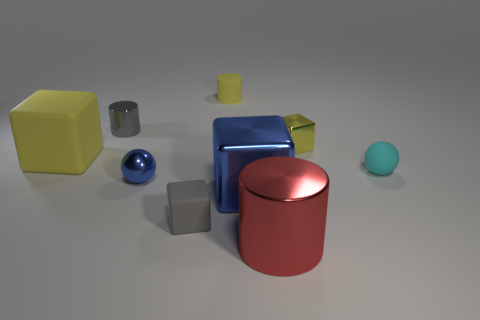Is the color of the big cylinder the same as the large rubber block?
Offer a terse response. No. How many blue shiny blocks are right of the cylinder in front of the tiny yellow block?
Keep it short and to the point. 0. Is the material of the yellow cube that is on the right side of the large yellow block the same as the tiny gray thing behind the tiny cyan ball?
Provide a succinct answer. Yes. What number of large red metal things are the same shape as the small gray rubber thing?
Give a very brief answer. 0. How many other rubber cubes are the same color as the large rubber block?
Make the answer very short. 0. There is a big metal object that is behind the small matte cube; does it have the same shape as the small shiny thing on the right side of the large blue shiny object?
Provide a short and direct response. Yes. There is a metallic cylinder in front of the large cube behind the cyan ball; what number of big metal objects are left of it?
Offer a terse response. 1. What is the tiny cylinder in front of the small matte object behind the cylinder that is left of the small yellow rubber object made of?
Provide a short and direct response. Metal. Are the ball right of the gray matte cube and the gray block made of the same material?
Give a very brief answer. Yes. How many gray metal cylinders have the same size as the rubber cylinder?
Your answer should be compact. 1. 